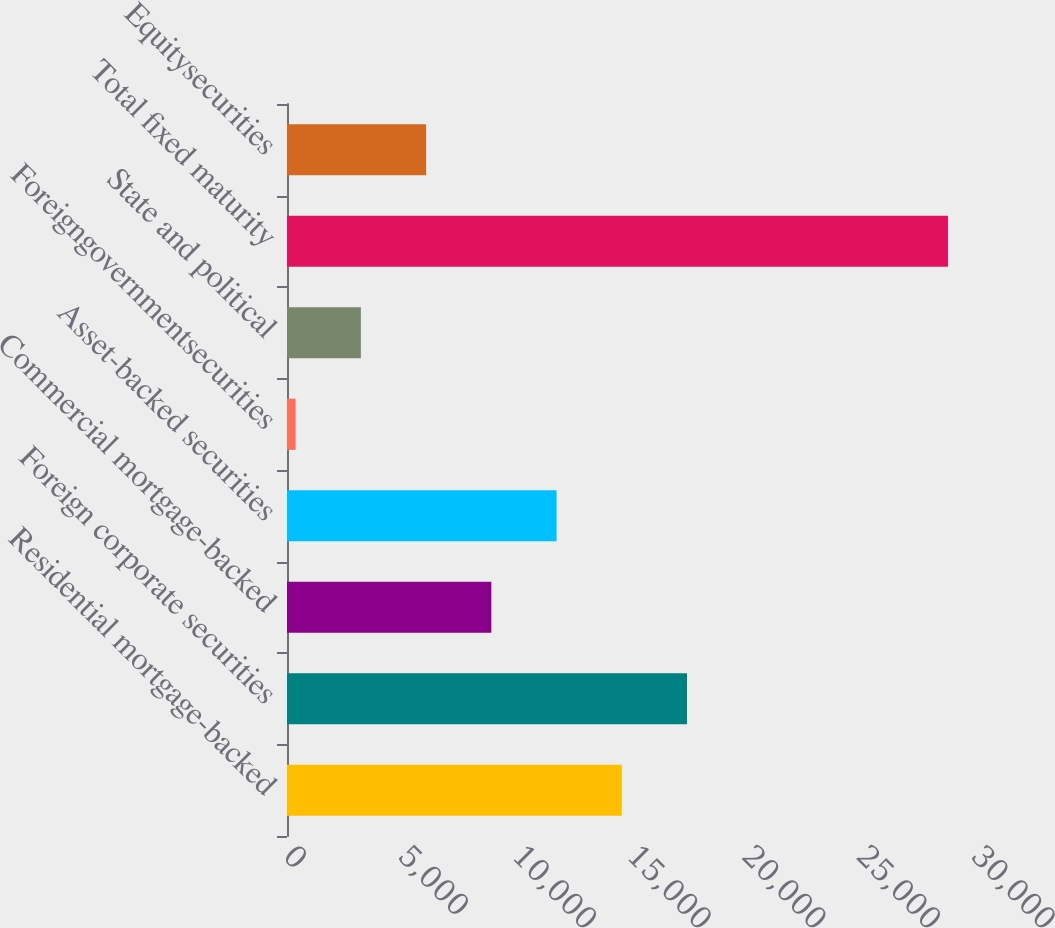Convert chart. <chart><loc_0><loc_0><loc_500><loc_500><bar_chart><fcel>Residential mortgage-backed<fcel>Foreign corporate securities<fcel>Commercial mortgage-backed<fcel>Asset-backed securities<fcel>Foreigngovernmentsecurities<fcel>State and political<fcel>Total fixed maturity<fcel>Equitysecurities<nl><fcel>14599<fcel>17443.4<fcel>8910.2<fcel>11754.6<fcel>377<fcel>3221.4<fcel>28821<fcel>6065.8<nl></chart> 